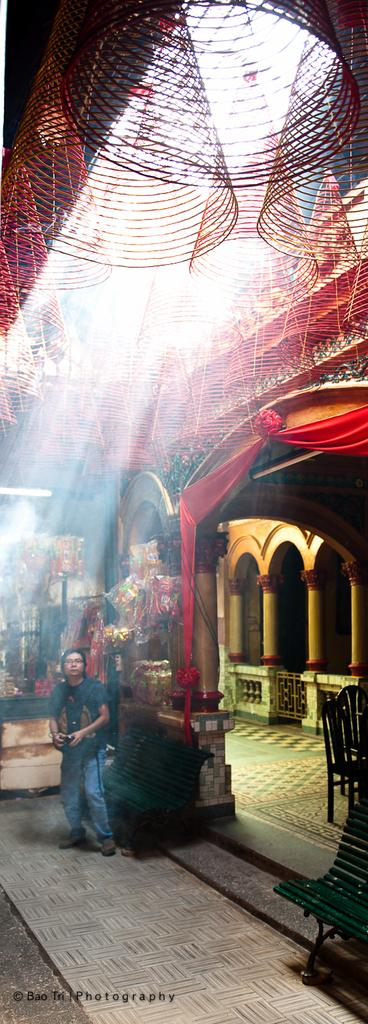What is the main setting of the image? There is a room in the image. What can be seen inside the room? There are people standing in the room and flowers are present. How would you describe the weather or lighting in the image? The background of the image is sunny. What type of caption is written on the flowers in the image? There is no caption written on the flowers in the image; they are simply flowers. 